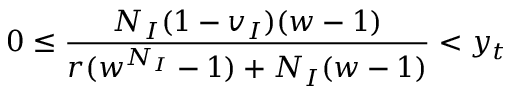<formula> <loc_0><loc_0><loc_500><loc_500>0 \leq \frac { N _ { I } ( 1 - v _ { I } ) ( w - 1 ) } { r ( w ^ { N _ { I } } - 1 ) + N _ { I } ( w - 1 ) } < y _ { t }</formula> 